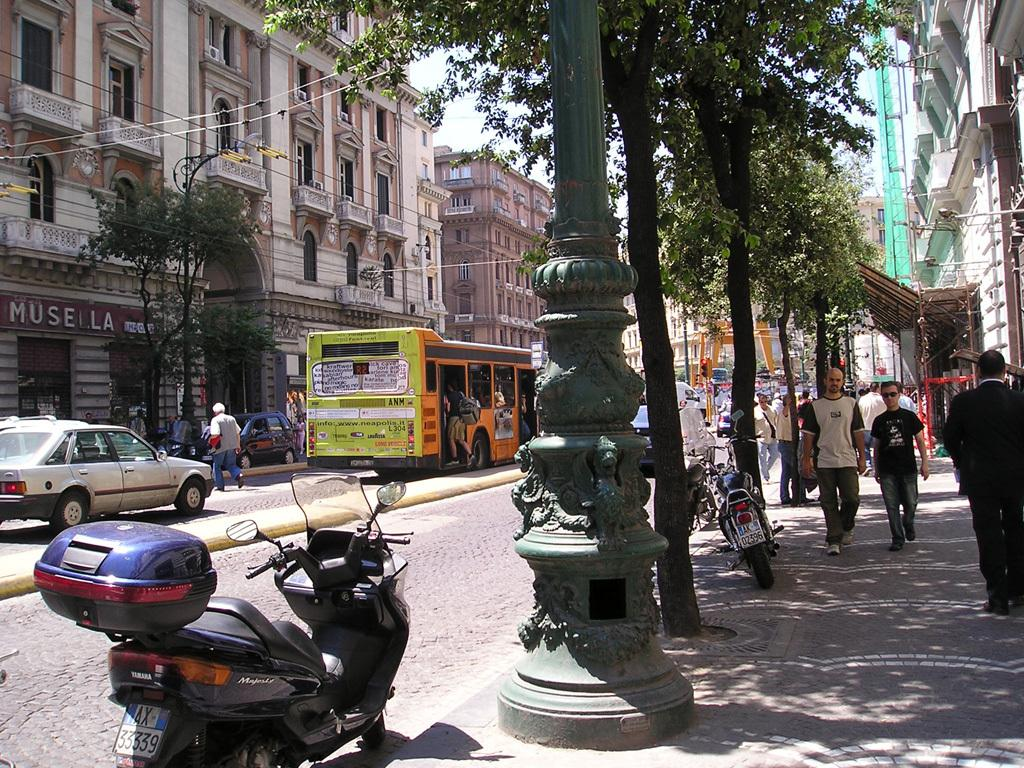What type of structures can be seen in the image? There are buildings in the image. What appliances are present on the buildings? Air conditioners are present in the image. What type of establishments can be found in the image? There are stores in the image. What mode of transportation is visible on the road? Motor vehicles are visible on the road. What are the people in the image doing? Persons are walking on both the footpath and the road. What architectural elements can be seen in the image? Pillars are present in the image. What type of natural elements are visible in the image? Trees are visible in the image. What part of the environment is visible in the image? The sky is visible in the image. Reasoning: Let' Let's think step by step in order to produce the conversation. We start by identifying the main subjects and objects in the image based on the provided facts. We then formulate questions that focus on the location and characteristics of these subjects and objects, ensuring that each question can be answered definitively with the information given. We avoid yes/no questions and ensure that the language is simple and clear. Absurd Question/Answer: Where is the basket of lace located in the image? There is no basket of lace present in the image. What type of drawer can be seen in the image? There are no drawers present in the image. Where is the basket of lace located in the image? There is no basket of lace present in the image. What type of drawer can be seen in the image? There are no drawers present in the image. 